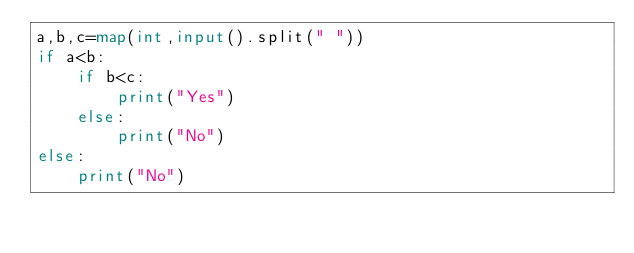Convert code to text. <code><loc_0><loc_0><loc_500><loc_500><_Python_>a,b,c=map(int,input().split(" "))
if a<b:
    if b<c:
        print("Yes")
    else:
        print("No")
else:
    print("No")
</code> 